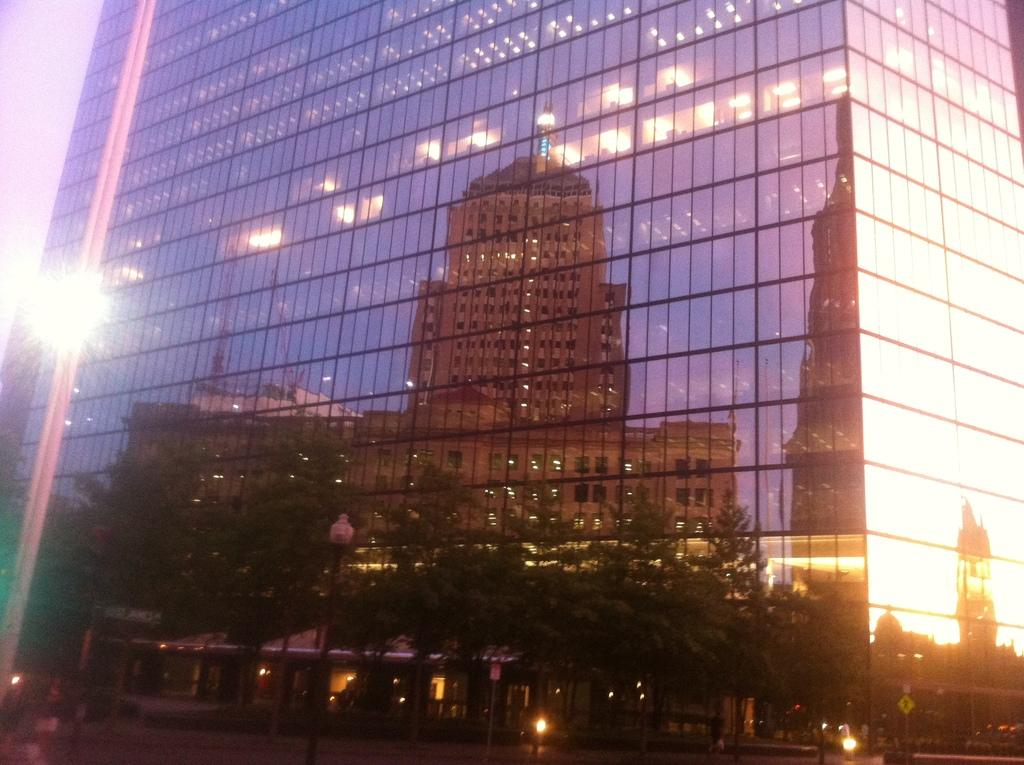What is the main subject of the image? The main subject of the image is a building. What can be observed about the building's appearance in the image? The building has a reflection in the image. What elements are included in the building's reflection? The reflection includes other buildings, trees, and lights. What type of silverware is visible in the image? There is no silverware present in the image; it features a building with a reflection. How many friends are sitting on the bench in the image? There is no bench or friends present in the image; it features a building with a reflection. 